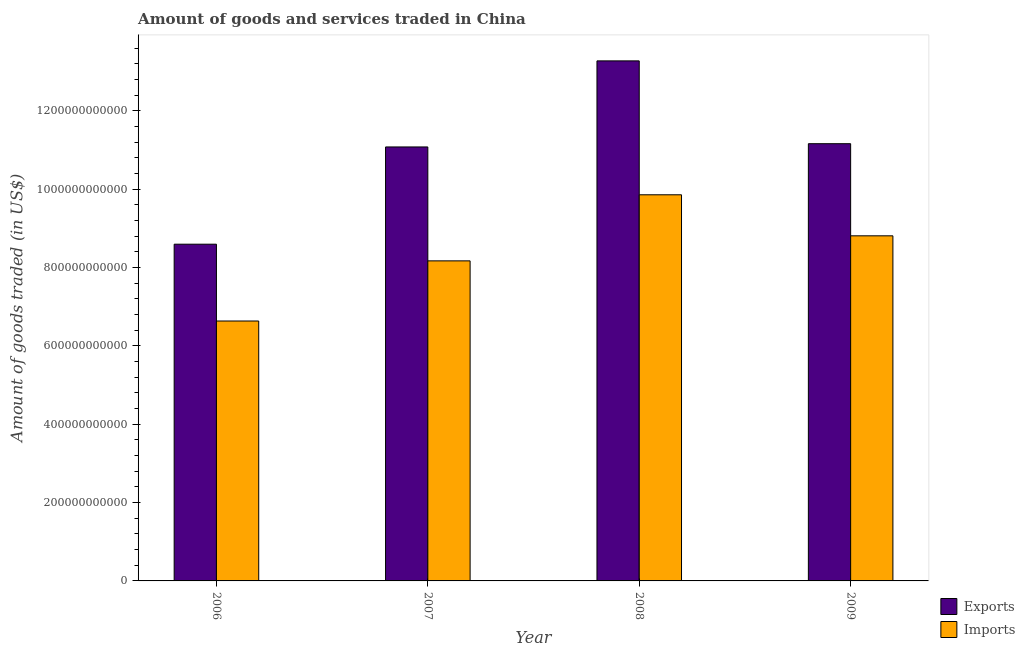How many different coloured bars are there?
Offer a very short reply. 2. Are the number of bars per tick equal to the number of legend labels?
Offer a terse response. Yes. How many bars are there on the 2nd tick from the right?
Provide a short and direct response. 2. What is the label of the 4th group of bars from the left?
Offer a terse response. 2009. What is the amount of goods exported in 2007?
Make the answer very short. 1.11e+12. Across all years, what is the maximum amount of goods imported?
Provide a short and direct response. 9.86e+11. Across all years, what is the minimum amount of goods exported?
Keep it short and to the point. 8.60e+11. In which year was the amount of goods exported minimum?
Your answer should be compact. 2006. What is the total amount of goods exported in the graph?
Your answer should be compact. 4.41e+12. What is the difference between the amount of goods exported in 2008 and that in 2009?
Offer a very short reply. 2.11e+11. What is the difference between the amount of goods imported in 2008 and the amount of goods exported in 2007?
Make the answer very short. 1.69e+11. What is the average amount of goods imported per year?
Offer a very short reply. 8.37e+11. In the year 2006, what is the difference between the amount of goods imported and amount of goods exported?
Keep it short and to the point. 0. What is the ratio of the amount of goods imported in 2006 to that in 2008?
Your answer should be compact. 0.67. Is the amount of goods imported in 2006 less than that in 2009?
Offer a terse response. Yes. What is the difference between the highest and the second highest amount of goods imported?
Your answer should be compact. 1.05e+11. What is the difference between the highest and the lowest amount of goods exported?
Your response must be concise. 4.68e+11. What does the 1st bar from the left in 2007 represents?
Make the answer very short. Exports. What does the 1st bar from the right in 2008 represents?
Your response must be concise. Imports. How many bars are there?
Your response must be concise. 8. Are all the bars in the graph horizontal?
Keep it short and to the point. No. What is the difference between two consecutive major ticks on the Y-axis?
Give a very brief answer. 2.00e+11. Does the graph contain grids?
Your answer should be very brief. No. How many legend labels are there?
Provide a succinct answer. 2. How are the legend labels stacked?
Keep it short and to the point. Vertical. What is the title of the graph?
Your response must be concise. Amount of goods and services traded in China. Does "Sanitation services" appear as one of the legend labels in the graph?
Make the answer very short. No. What is the label or title of the Y-axis?
Keep it short and to the point. Amount of goods traded (in US$). What is the Amount of goods traded (in US$) of Exports in 2006?
Give a very brief answer. 8.60e+11. What is the Amount of goods traded (in US$) of Imports in 2006?
Ensure brevity in your answer.  6.64e+11. What is the Amount of goods traded (in US$) of Exports in 2007?
Offer a terse response. 1.11e+12. What is the Amount of goods traded (in US$) in Imports in 2007?
Your response must be concise. 8.17e+11. What is the Amount of goods traded (in US$) in Exports in 2008?
Your response must be concise. 1.33e+12. What is the Amount of goods traded (in US$) in Imports in 2008?
Give a very brief answer. 9.86e+11. What is the Amount of goods traded (in US$) of Exports in 2009?
Offer a very short reply. 1.12e+12. What is the Amount of goods traded (in US$) of Imports in 2009?
Your answer should be very brief. 8.81e+11. Across all years, what is the maximum Amount of goods traded (in US$) in Exports?
Provide a succinct answer. 1.33e+12. Across all years, what is the maximum Amount of goods traded (in US$) in Imports?
Your answer should be compact. 9.86e+11. Across all years, what is the minimum Amount of goods traded (in US$) in Exports?
Offer a very short reply. 8.60e+11. Across all years, what is the minimum Amount of goods traded (in US$) in Imports?
Provide a succinct answer. 6.64e+11. What is the total Amount of goods traded (in US$) of Exports in the graph?
Ensure brevity in your answer.  4.41e+12. What is the total Amount of goods traded (in US$) of Imports in the graph?
Offer a terse response. 3.35e+12. What is the difference between the Amount of goods traded (in US$) of Exports in 2006 and that in 2007?
Your answer should be compact. -2.48e+11. What is the difference between the Amount of goods traded (in US$) of Imports in 2006 and that in 2007?
Provide a succinct answer. -1.54e+11. What is the difference between the Amount of goods traded (in US$) of Exports in 2006 and that in 2008?
Offer a terse response. -4.68e+11. What is the difference between the Amount of goods traded (in US$) in Imports in 2006 and that in 2008?
Offer a terse response. -3.22e+11. What is the difference between the Amount of goods traded (in US$) in Exports in 2006 and that in 2009?
Keep it short and to the point. -2.57e+11. What is the difference between the Amount of goods traded (in US$) in Imports in 2006 and that in 2009?
Your answer should be compact. -2.17e+11. What is the difference between the Amount of goods traded (in US$) in Exports in 2007 and that in 2008?
Your response must be concise. -2.20e+11. What is the difference between the Amount of goods traded (in US$) in Imports in 2007 and that in 2008?
Give a very brief answer. -1.69e+11. What is the difference between the Amount of goods traded (in US$) in Exports in 2007 and that in 2009?
Provide a short and direct response. -8.30e+09. What is the difference between the Amount of goods traded (in US$) of Imports in 2007 and that in 2009?
Provide a succinct answer. -6.39e+1. What is the difference between the Amount of goods traded (in US$) in Exports in 2008 and that in 2009?
Provide a short and direct response. 2.11e+11. What is the difference between the Amount of goods traded (in US$) in Imports in 2008 and that in 2009?
Give a very brief answer. 1.05e+11. What is the difference between the Amount of goods traded (in US$) of Exports in 2006 and the Amount of goods traded (in US$) of Imports in 2007?
Give a very brief answer. 4.26e+1. What is the difference between the Amount of goods traded (in US$) in Exports in 2006 and the Amount of goods traded (in US$) in Imports in 2008?
Your answer should be very brief. -1.26e+11. What is the difference between the Amount of goods traded (in US$) of Exports in 2006 and the Amount of goods traded (in US$) of Imports in 2009?
Your response must be concise. -2.14e+1. What is the difference between the Amount of goods traded (in US$) in Exports in 2007 and the Amount of goods traded (in US$) in Imports in 2008?
Give a very brief answer. 1.22e+11. What is the difference between the Amount of goods traded (in US$) in Exports in 2007 and the Amount of goods traded (in US$) in Imports in 2009?
Keep it short and to the point. 2.27e+11. What is the difference between the Amount of goods traded (in US$) in Exports in 2008 and the Amount of goods traded (in US$) in Imports in 2009?
Ensure brevity in your answer.  4.47e+11. What is the average Amount of goods traded (in US$) in Exports per year?
Your response must be concise. 1.10e+12. What is the average Amount of goods traded (in US$) of Imports per year?
Make the answer very short. 8.37e+11. In the year 2006, what is the difference between the Amount of goods traded (in US$) of Exports and Amount of goods traded (in US$) of Imports?
Provide a succinct answer. 1.96e+11. In the year 2007, what is the difference between the Amount of goods traded (in US$) of Exports and Amount of goods traded (in US$) of Imports?
Your answer should be very brief. 2.91e+11. In the year 2008, what is the difference between the Amount of goods traded (in US$) of Exports and Amount of goods traded (in US$) of Imports?
Your answer should be very brief. 3.42e+11. In the year 2009, what is the difference between the Amount of goods traded (in US$) of Exports and Amount of goods traded (in US$) of Imports?
Offer a very short reply. 2.35e+11. What is the ratio of the Amount of goods traded (in US$) in Exports in 2006 to that in 2007?
Provide a short and direct response. 0.78. What is the ratio of the Amount of goods traded (in US$) in Imports in 2006 to that in 2007?
Offer a terse response. 0.81. What is the ratio of the Amount of goods traded (in US$) in Exports in 2006 to that in 2008?
Make the answer very short. 0.65. What is the ratio of the Amount of goods traded (in US$) of Imports in 2006 to that in 2008?
Offer a terse response. 0.67. What is the ratio of the Amount of goods traded (in US$) in Exports in 2006 to that in 2009?
Your answer should be compact. 0.77. What is the ratio of the Amount of goods traded (in US$) in Imports in 2006 to that in 2009?
Your response must be concise. 0.75. What is the ratio of the Amount of goods traded (in US$) of Exports in 2007 to that in 2008?
Provide a short and direct response. 0.83. What is the ratio of the Amount of goods traded (in US$) of Imports in 2007 to that in 2008?
Keep it short and to the point. 0.83. What is the ratio of the Amount of goods traded (in US$) in Imports in 2007 to that in 2009?
Offer a very short reply. 0.93. What is the ratio of the Amount of goods traded (in US$) of Exports in 2008 to that in 2009?
Make the answer very short. 1.19. What is the ratio of the Amount of goods traded (in US$) in Imports in 2008 to that in 2009?
Your answer should be compact. 1.12. What is the difference between the highest and the second highest Amount of goods traded (in US$) in Exports?
Provide a short and direct response. 2.11e+11. What is the difference between the highest and the second highest Amount of goods traded (in US$) in Imports?
Give a very brief answer. 1.05e+11. What is the difference between the highest and the lowest Amount of goods traded (in US$) of Exports?
Offer a terse response. 4.68e+11. What is the difference between the highest and the lowest Amount of goods traded (in US$) in Imports?
Offer a very short reply. 3.22e+11. 